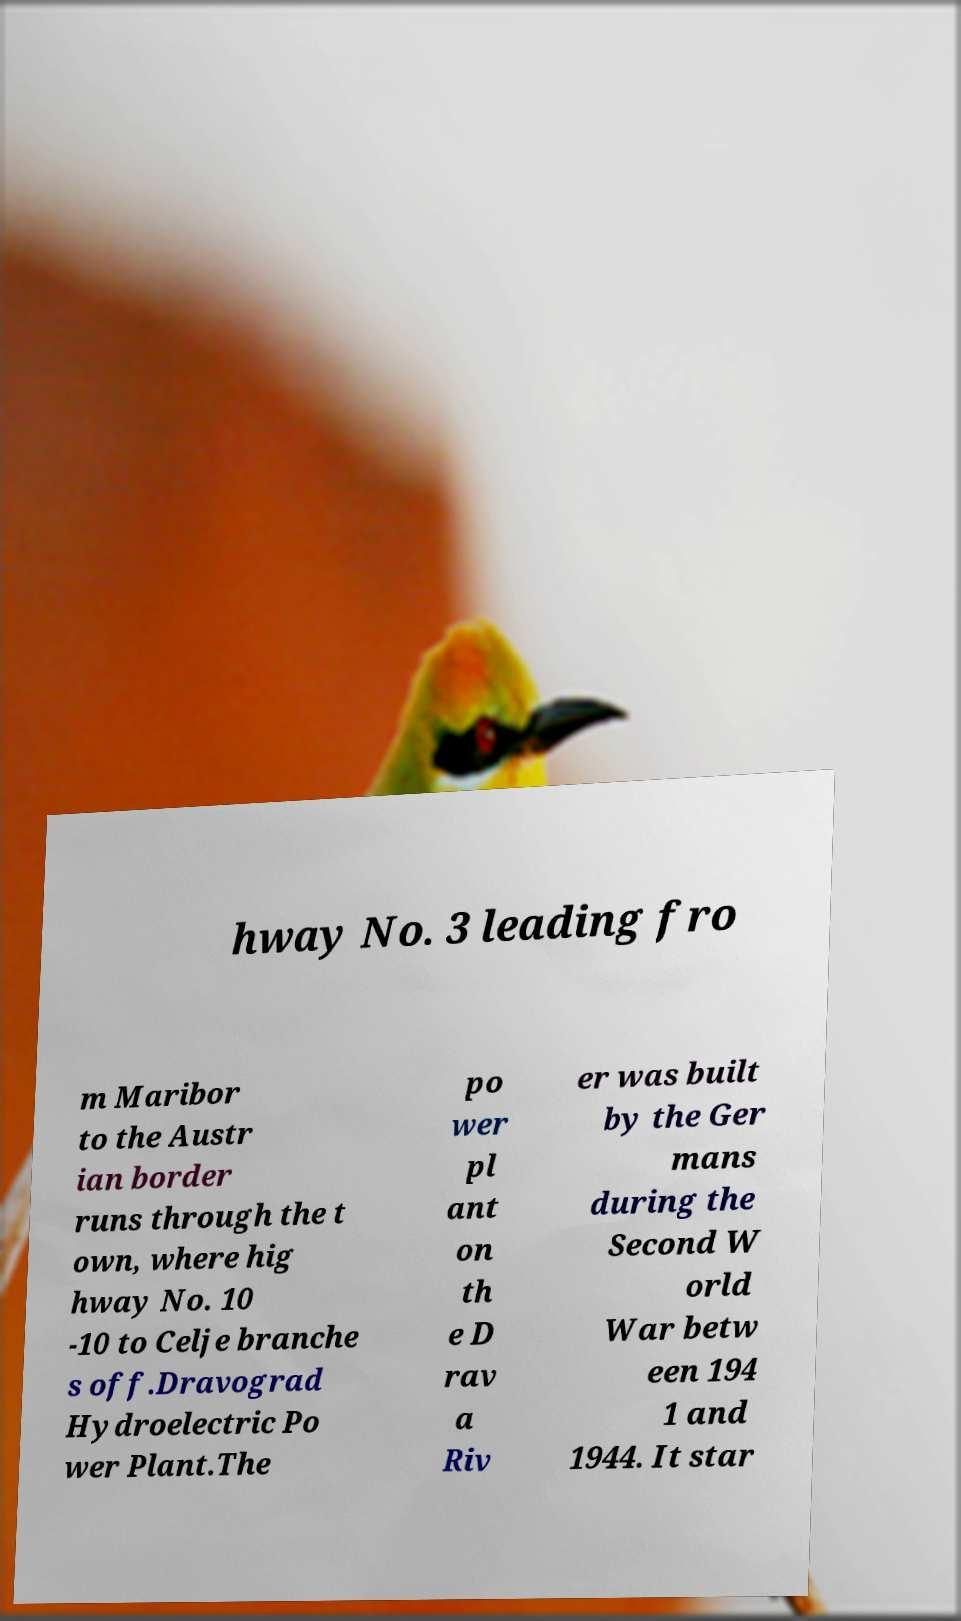Please read and relay the text visible in this image. What does it say? hway No. 3 leading fro m Maribor to the Austr ian border runs through the t own, where hig hway No. 10 -10 to Celje branche s off.Dravograd Hydroelectric Po wer Plant.The po wer pl ant on th e D rav a Riv er was built by the Ger mans during the Second W orld War betw een 194 1 and 1944. It star 